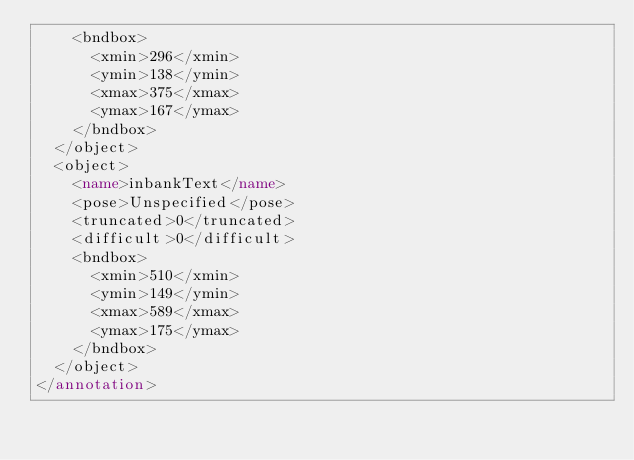<code> <loc_0><loc_0><loc_500><loc_500><_XML_>		<bndbox>
			<xmin>296</xmin>
			<ymin>138</ymin>
			<xmax>375</xmax>
			<ymax>167</ymax>
		</bndbox>
	</object>
	<object>
		<name>inbankText</name>
		<pose>Unspecified</pose>
		<truncated>0</truncated>
		<difficult>0</difficult>
		<bndbox>
			<xmin>510</xmin>
			<ymin>149</ymin>
			<xmax>589</xmax>
			<ymax>175</ymax>
		</bndbox>
	</object>
</annotation>
</code> 